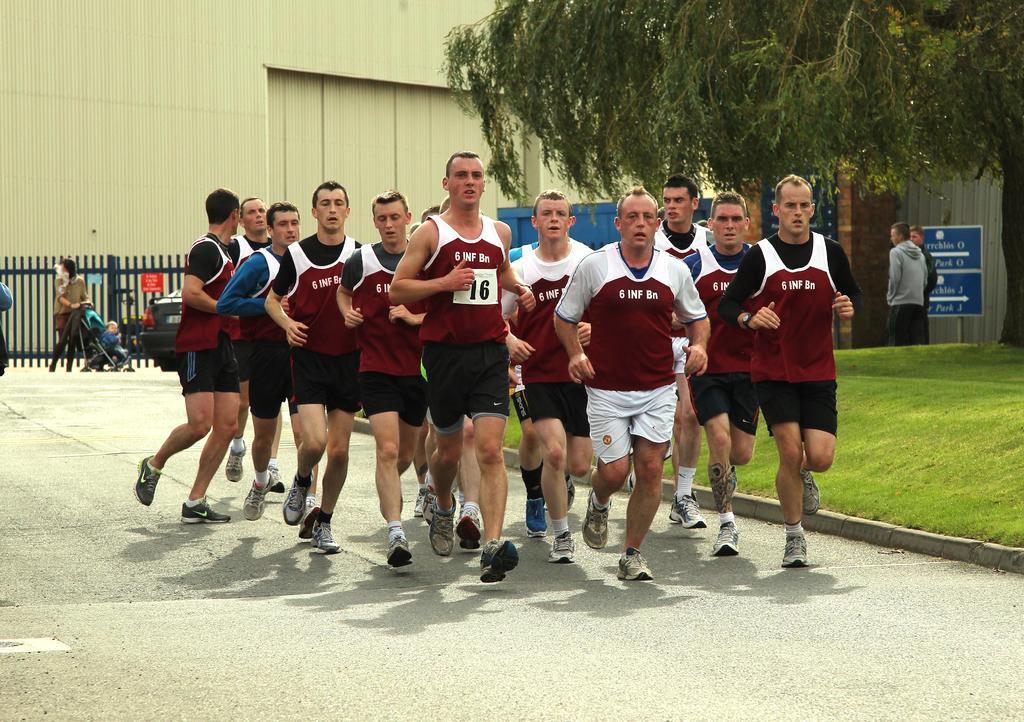Can you describe this image briefly? This picture is clicked outside the foreground can see the group of people wearing t-shirts and running on the ground and we can see the text on the T-Shirts and write the green grass and you can see the text on the board and two people standing on the ground the background you can see the building fence a person holding US dollar and standing on the ground and you can see a vehicle and some other objects and we can see a kid sitting in the stroller the left corner of a single I think and you can see the text on the poster seems to be attached to the penis 